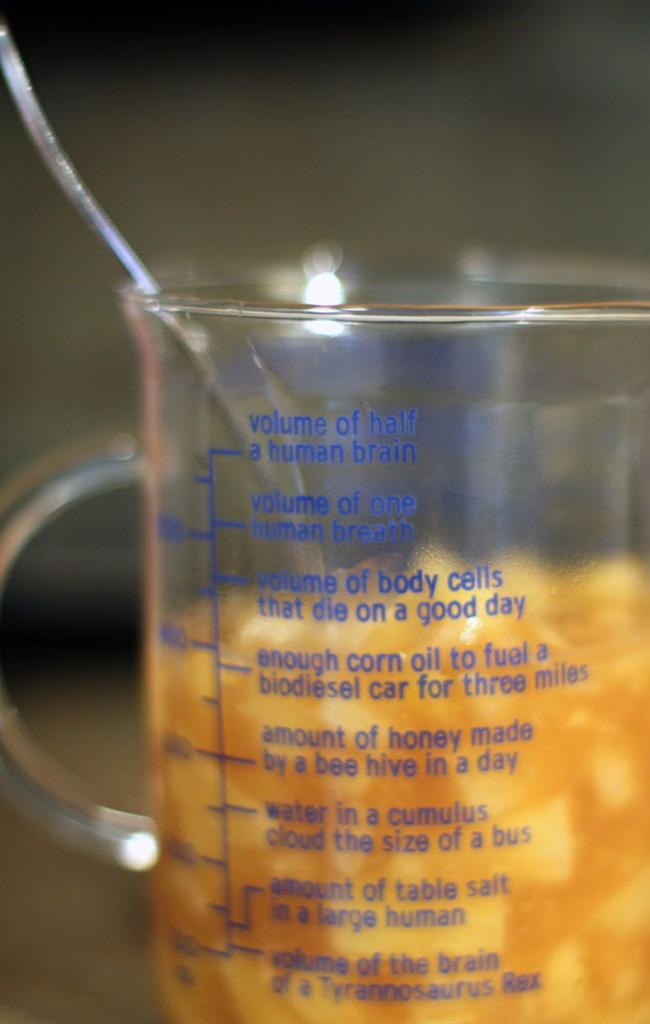<image>
Describe the image concisely. a glass beaker that says amount of honey made by a bee in a day 